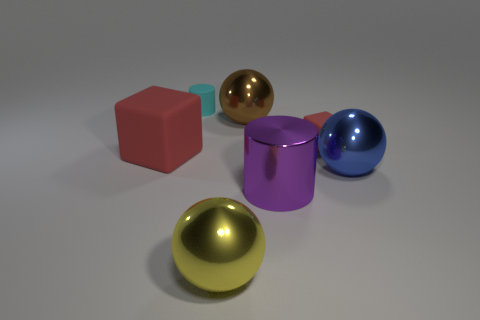Does the small rubber object on the right side of the metal cylinder have the same color as the big cube?
Offer a terse response. Yes. What size is the metallic cylinder?
Your answer should be compact. Large. How many other things are there of the same color as the tiny matte cylinder?
Your response must be concise. 0. There is a thing that is both right of the purple cylinder and in front of the big red matte object; what color is it?
Your response must be concise. Blue. What number of big cyan rubber cylinders are there?
Provide a succinct answer. 0. Are the large brown ball and the yellow object made of the same material?
Offer a very short reply. Yes. There is a red matte object in front of the red object behind the cube on the left side of the small red object; what shape is it?
Make the answer very short. Cube. Does the red thing on the right side of the large yellow shiny object have the same material as the thing behind the big brown sphere?
Provide a short and direct response. Yes. What is the material of the big red object?
Your answer should be very brief. Rubber. What number of tiny cyan things have the same shape as the purple thing?
Keep it short and to the point. 1. 